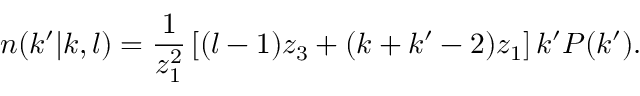Convert formula to latex. <formula><loc_0><loc_0><loc_500><loc_500>n ( k ^ { \prime } | k , l ) = \frac { 1 } { z _ { 1 } ^ { 2 } } \left [ ( l - 1 ) z _ { 3 } + ( k + k ^ { \prime } - 2 ) z _ { 1 } \right ] k ^ { \prime } P ( k ^ { \prime } ) .</formula> 